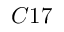Convert formula to latex. <formula><loc_0><loc_0><loc_500><loc_500>C 1 7</formula> 